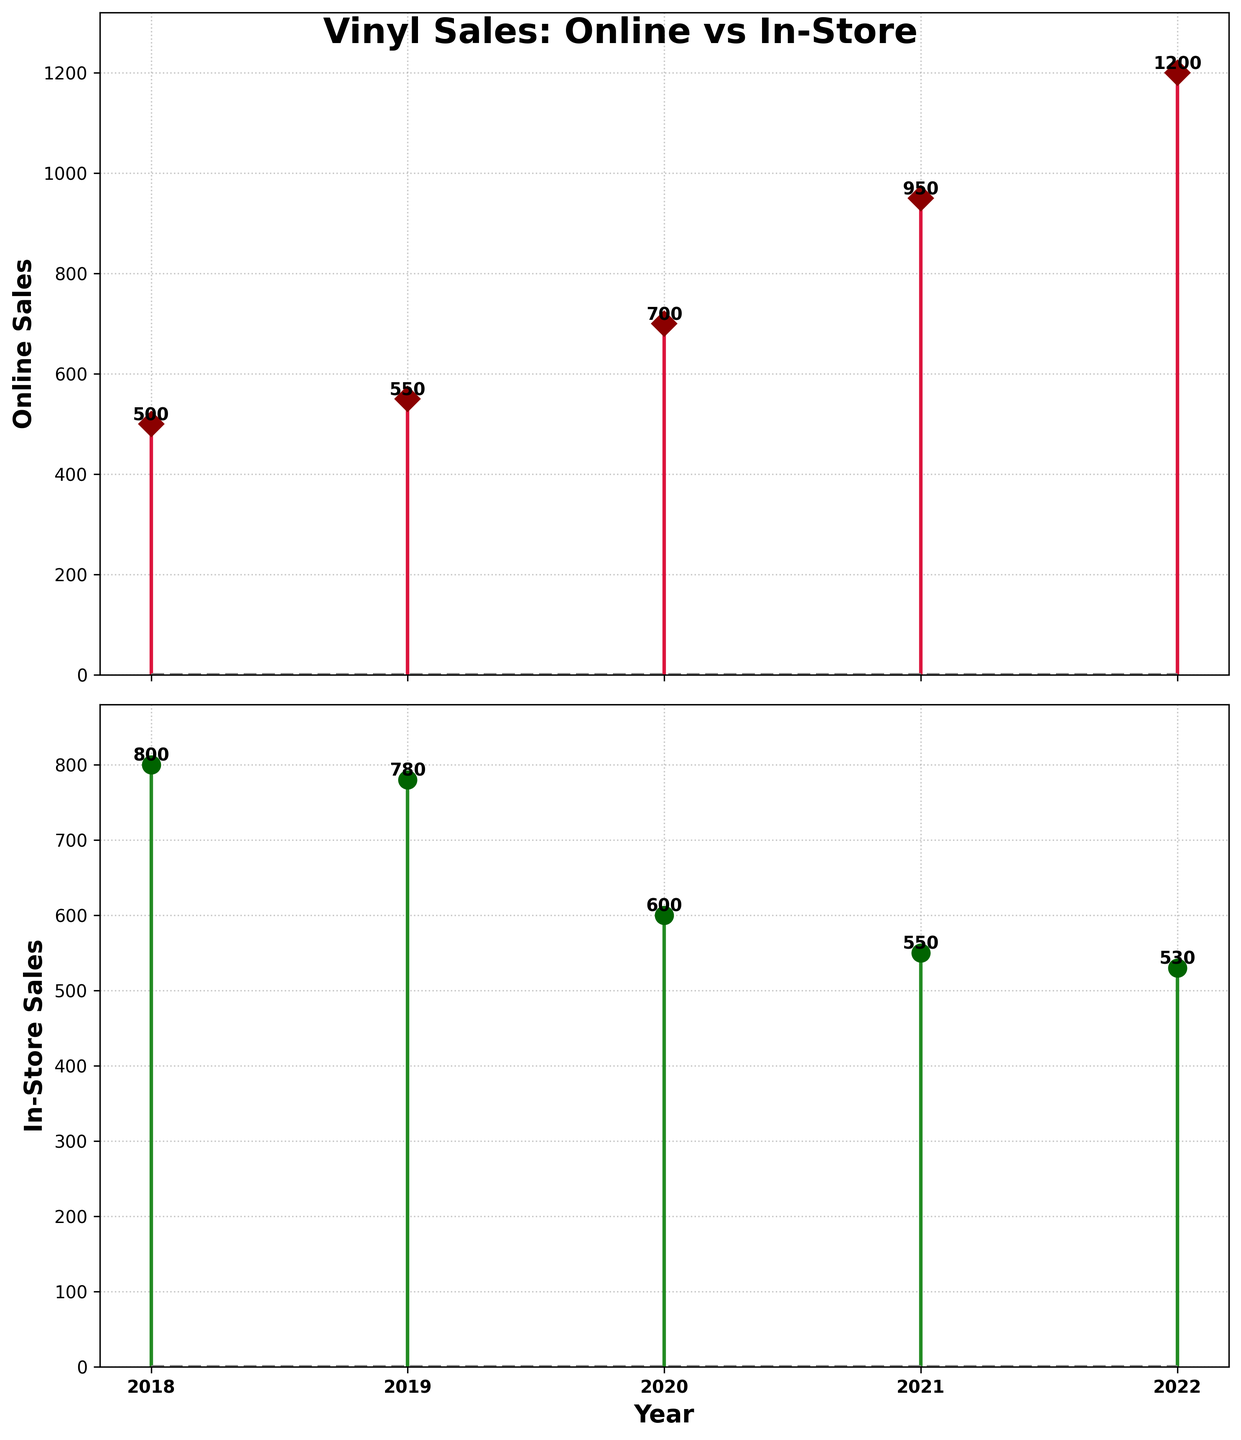what is the title of the figure? The title is displayed at the top of the figure and reads "Vinyl Sales: Online vs In-Store".
Answer: Vinyl Sales: Online vs In-Store what are the types of sales being compared? The figure compares two types of sales: 'Online' and 'In-Store'. This information is clearly shown by the labels on each subplot, where the top subplot is for 'Online Sales' and the bottom subplot is for 'In-Store Sales'.
Answer: Online and In-Store what is the maximum value of in-store sales? The maximum value of in-store sales is found by looking at the heights of the stem lines in the bottom subplot. The highest point is 800 in the year 2018.
Answer: 800 in which year did online sales see the highest increase from the previous year? To find the year with the highest increase in online sales, look at the difference between consecutive years' sales values. From 2020 to 2021, sales increased from 700 to 950, which is the largest increase.
Answer: 2021 how did in-store sales change from 2018 to 2022? To track the change, observe the in-store sales values for 2018 and 2022. In-Store sales decreased from 800 in 2018 to 530 in 2022.
Answer: Decreased which type of sales had a higher value in 2020? In 2020, the online sales value is 700 while the in-store sales value is 600. Therefore, the online sales had a higher value.
Answer: Online how do the patterns of online and in-store sales compare over the years? The pattern of online sales shows a general increasing trend, whereas in-store sales have a general decreasing trend over the same period from 2018 to 2022. This can be observed by comparing the heights of the stem lines in both subplots.
Answer: Online sales increased, In-Store sales decreased which year had the smallest difference between online and in-store sales? Calculate the differences between online and in-store sales for each year:
2018: 800 - 500 = 300
2019: 780 - 550 = 230
2020: 700 - 600 = 100
2021: 550 - 950 = -400
2022: 530 - 1200 = -670
The smallest difference is in 2020 with a difference of 100.
Answer: 2020 what's the sum of in-store sales from 2018 to 2022? Add up the in-store sales for all the years:
800 + 780 + 600 + 550 + 530 = 3260
Answer: 3260 what color is used for the markers in the online sales subplot? The markers in the online sales subplot are colored dark red, as indicated by their distinctive color.
Answer: Dark red 